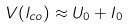<formula> <loc_0><loc_0><loc_500><loc_500>V ( l _ { c o } ) \approx U _ { 0 } + I _ { 0 }</formula> 